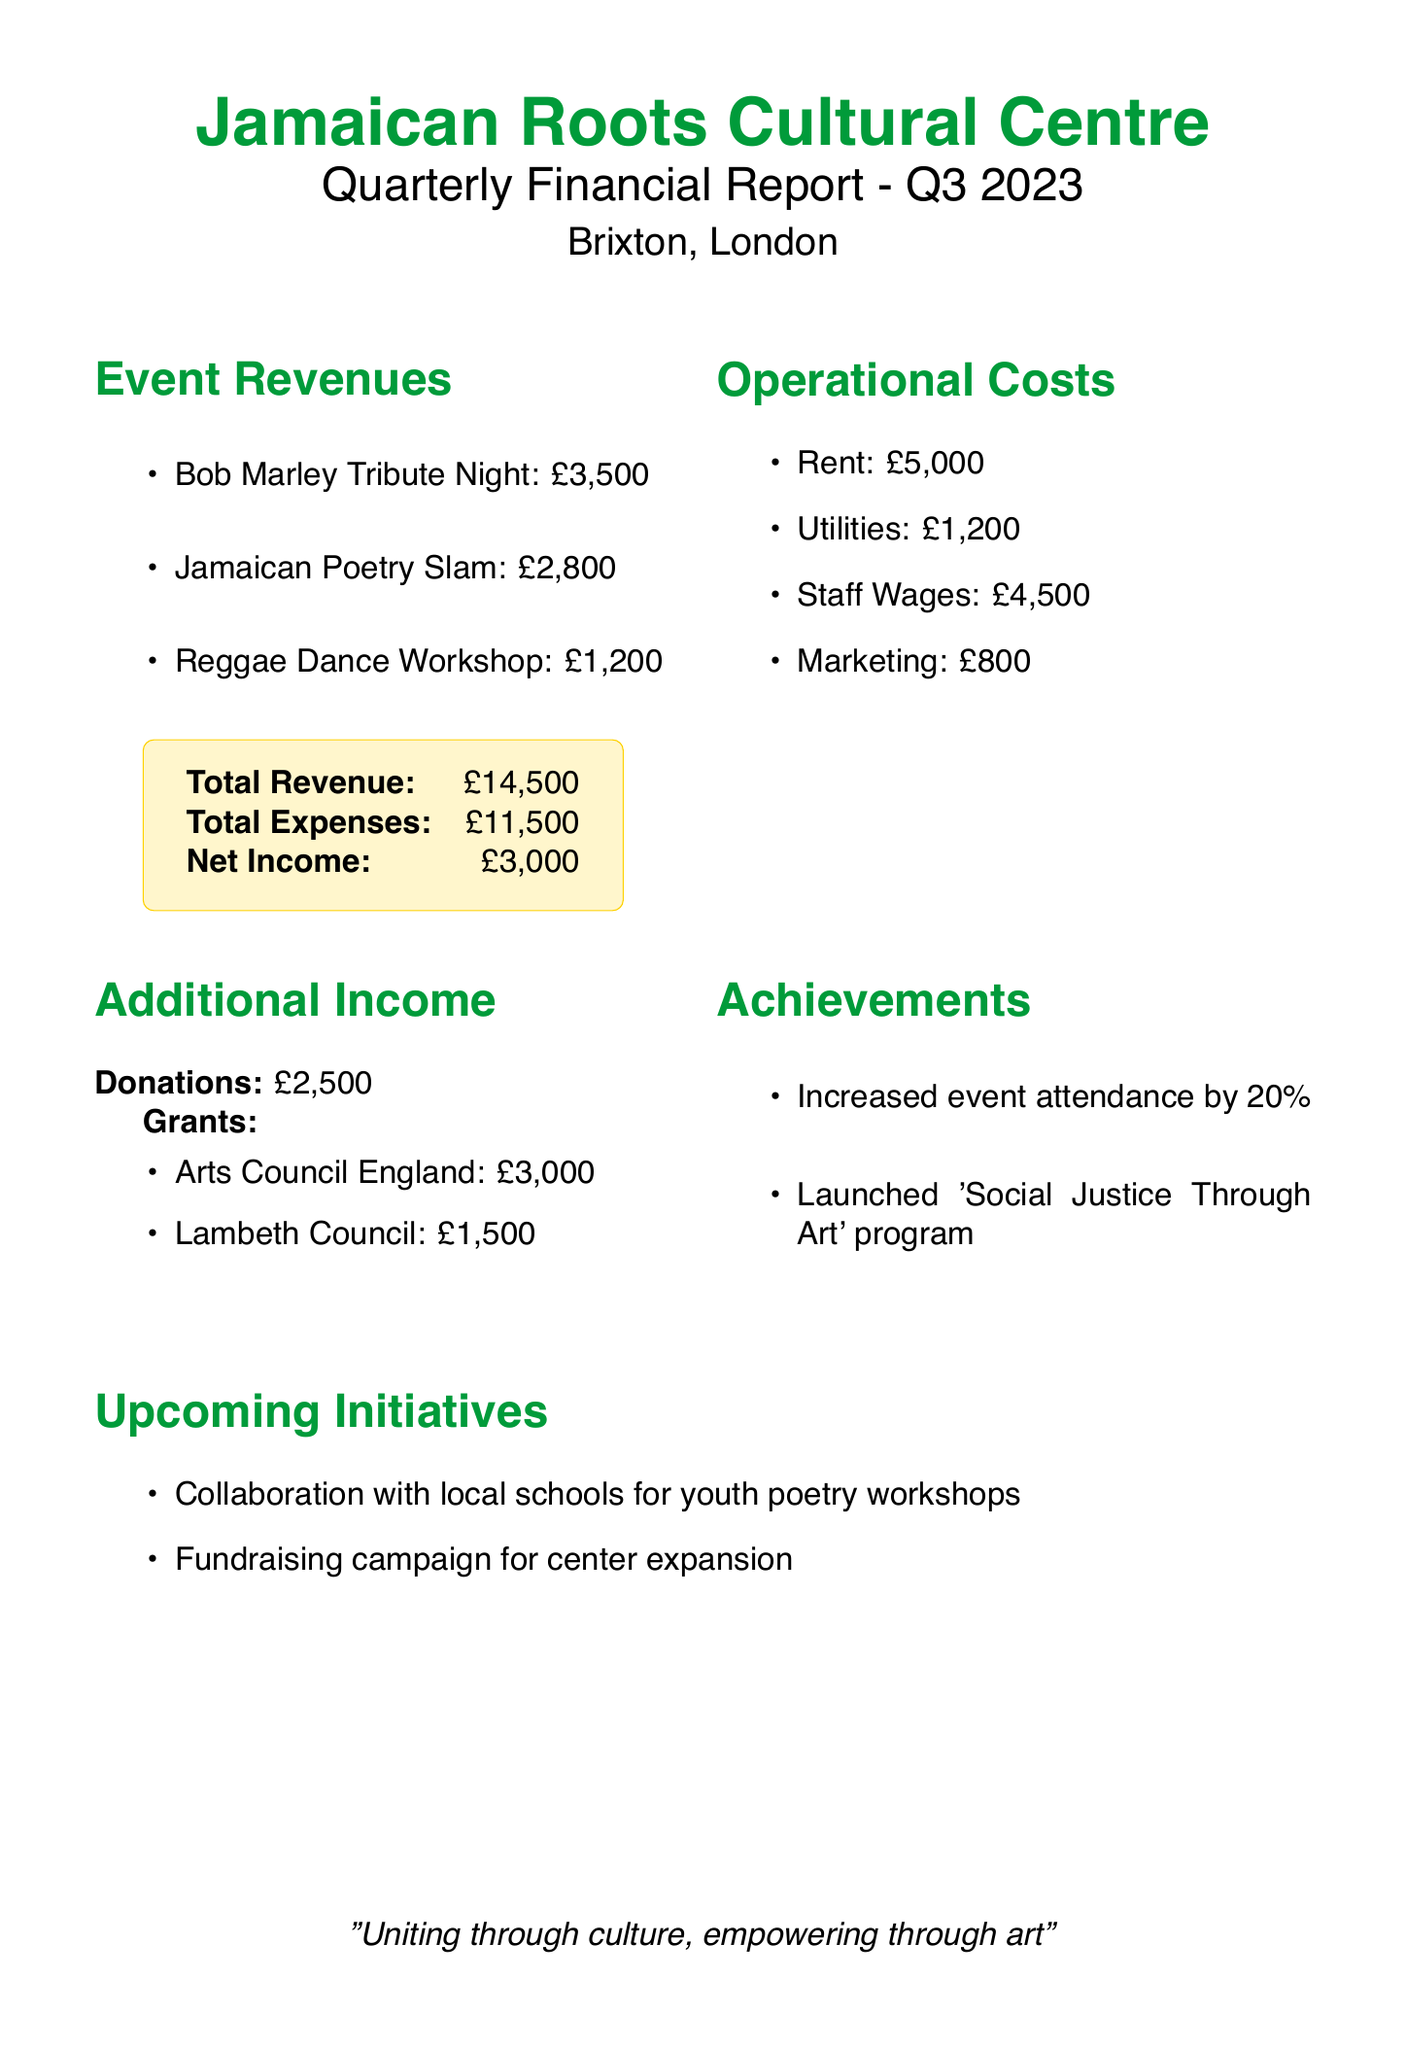What is the center's name? The center's name is mentioned at the beginning of the document.
Answer: Jamaican Roots Cultural Centre What was the net income for Q3 2023? The net income is calculated as total revenue minus total expenses, which is stated in the financial summary.
Answer: £3,000 What was the revenue from the Jamaican Poetry Slam event? The revenue from the Jamaican Poetry Slam is clearly listed under event revenues in the document.
Answer: £2,800 What is the total expense amount? The total expense is provided in the financial summary section of the document.
Answer: £11,500 What are the upcoming initiatives mentioned? The upcoming initiatives are listed toward the end of the document.
Answer: Collaboration with local schools for youth poetry workshops, Fundraising campaign for center expansion How much was received in grants from Arts Council England? The specific grant amount received from Arts Council England is listed under additional income.
Answer: £3,000 Did the event attendance increase or decrease compared to the previous quarter? The document highlights an increase in event attendance compared to the previous quarter.
Answer: Increased What was the amount spent on marketing? The amount spent on marketing is specifically detailed under operational costs.
Answer: £800 How much did the center receive in donations? The donation amount is explicitly stated in the additional income section of the document.
Answer: £2,500 